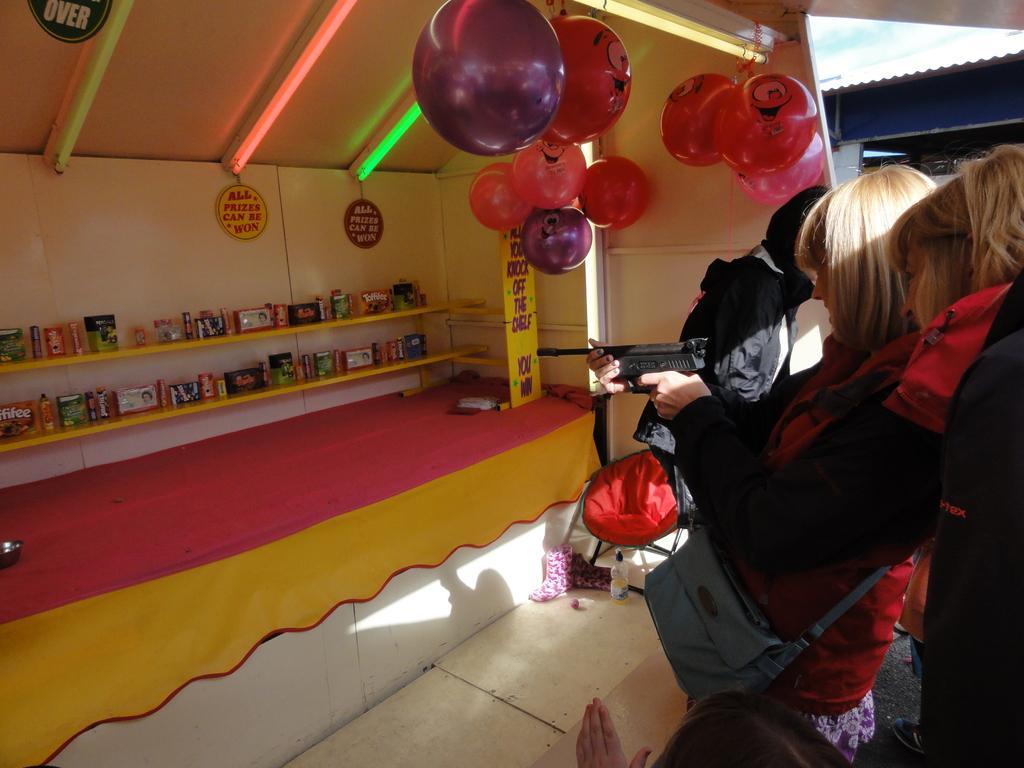How would you summarize this image in a sentence or two? In this picture we can see objects in the racks. Here we can see boards. These are balloons. We can see lights at the top. Here we can see people and this woman is holding a gun in her hands. This is a sling bag. 